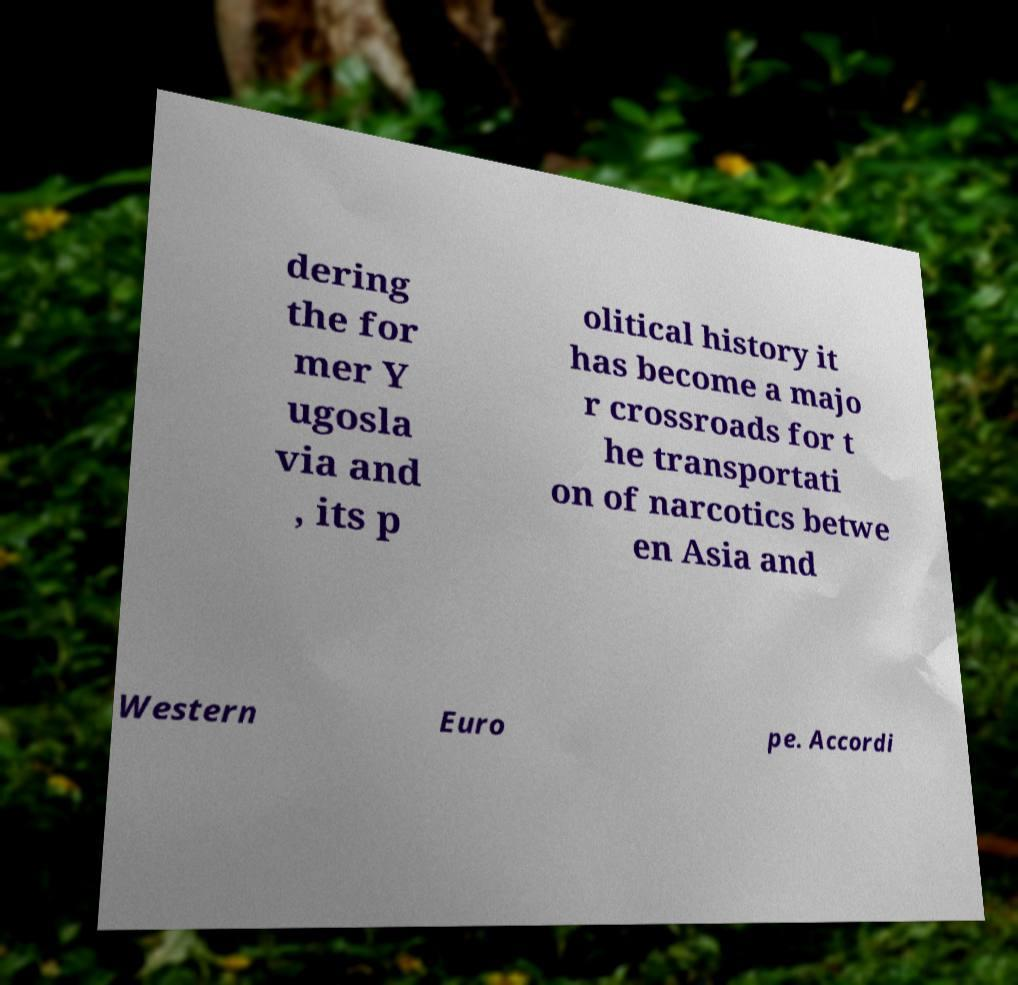Please identify and transcribe the text found in this image. dering the for mer Y ugosla via and , its p olitical history it has become a majo r crossroads for t he transportati on of narcotics betwe en Asia and Western Euro pe. Accordi 